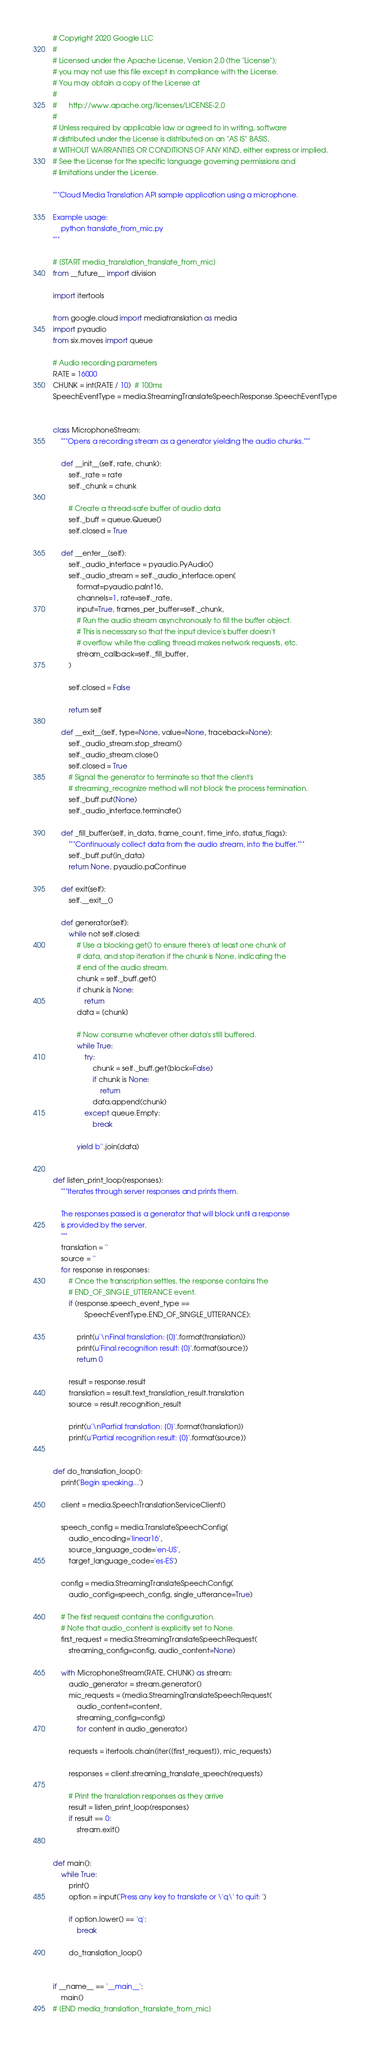<code> <loc_0><loc_0><loc_500><loc_500><_Python_># Copyright 2020 Google LLC
#
# Licensed under the Apache License, Version 2.0 (the "License");
# you may not use this file except in compliance with the License.
# You may obtain a copy of the License at
#
#      http://www.apache.org/licenses/LICENSE-2.0
#
# Unless required by applicable law or agreed to in writing, software
# distributed under the License is distributed on an "AS IS" BASIS,
# WITHOUT WARRANTIES OR CONDITIONS OF ANY KIND, either express or implied.
# See the License for the specific language governing permissions and
# limitations under the License.

"""Cloud Media Translation API sample application using a microphone.

Example usage:
    python translate_from_mic.py
"""

# [START media_translation_translate_from_mic]
from __future__ import division

import itertools

from google.cloud import mediatranslation as media
import pyaudio
from six.moves import queue

# Audio recording parameters
RATE = 16000
CHUNK = int(RATE / 10)  # 100ms
SpeechEventType = media.StreamingTranslateSpeechResponse.SpeechEventType


class MicrophoneStream:
    """Opens a recording stream as a generator yielding the audio chunks."""

    def __init__(self, rate, chunk):
        self._rate = rate
        self._chunk = chunk

        # Create a thread-safe buffer of audio data
        self._buff = queue.Queue()
        self.closed = True

    def __enter__(self):
        self._audio_interface = pyaudio.PyAudio()
        self._audio_stream = self._audio_interface.open(
            format=pyaudio.paInt16,
            channels=1, rate=self._rate,
            input=True, frames_per_buffer=self._chunk,
            # Run the audio stream asynchronously to fill the buffer object.
            # This is necessary so that the input device's buffer doesn't
            # overflow while the calling thread makes network requests, etc.
            stream_callback=self._fill_buffer,
        )

        self.closed = False

        return self

    def __exit__(self, type=None, value=None, traceback=None):
        self._audio_stream.stop_stream()
        self._audio_stream.close()
        self.closed = True
        # Signal the generator to terminate so that the client's
        # streaming_recognize method will not block the process termination.
        self._buff.put(None)
        self._audio_interface.terminate()

    def _fill_buffer(self, in_data, frame_count, time_info, status_flags):
        """Continuously collect data from the audio stream, into the buffer."""
        self._buff.put(in_data)
        return None, pyaudio.paContinue

    def exit(self):
        self.__exit__()

    def generator(self):
        while not self.closed:
            # Use a blocking get() to ensure there's at least one chunk of
            # data, and stop iteration if the chunk is None, indicating the
            # end of the audio stream.
            chunk = self._buff.get()
            if chunk is None:
                return
            data = [chunk]

            # Now consume whatever other data's still buffered.
            while True:
                try:
                    chunk = self._buff.get(block=False)
                    if chunk is None:
                        return
                    data.append(chunk)
                except queue.Empty:
                    break

            yield b''.join(data)


def listen_print_loop(responses):
    """Iterates through server responses and prints them.

    The responses passed is a generator that will block until a response
    is provided by the server.
    """
    translation = ''
    source = ''
    for response in responses:
        # Once the transcription settles, the response contains the
        # END_OF_SINGLE_UTTERANCE event.
        if (response.speech_event_type ==
                SpeechEventType.END_OF_SINGLE_UTTERANCE):

            print(u'\nFinal translation: {0}'.format(translation))
            print(u'Final recognition result: {0}'.format(source))
            return 0

        result = response.result
        translation = result.text_translation_result.translation
        source = result.recognition_result

        print(u'\nPartial translation: {0}'.format(translation))
        print(u'Partial recognition result: {0}'.format(source))


def do_translation_loop():
    print('Begin speaking...')

    client = media.SpeechTranslationServiceClient()

    speech_config = media.TranslateSpeechConfig(
        audio_encoding='linear16',
        source_language_code='en-US',
        target_language_code='es-ES')

    config = media.StreamingTranslateSpeechConfig(
        audio_config=speech_config, single_utterance=True)

    # The first request contains the configuration.
    # Note that audio_content is explicitly set to None.
    first_request = media.StreamingTranslateSpeechRequest(
        streaming_config=config, audio_content=None)

    with MicrophoneStream(RATE, CHUNK) as stream:
        audio_generator = stream.generator()
        mic_requests = (media.StreamingTranslateSpeechRequest(
            audio_content=content,
            streaming_config=config)
            for content in audio_generator)

        requests = itertools.chain(iter([first_request]), mic_requests)

        responses = client.streaming_translate_speech(requests)

        # Print the translation responses as they arrive
        result = listen_print_loop(responses)
        if result == 0:
            stream.exit()


def main():
    while True:
        print()
        option = input('Press any key to translate or \'q\' to quit: ')

        if option.lower() == 'q':
            break

        do_translation_loop()


if __name__ == '__main__':
    main()
# [END media_translation_translate_from_mic]
</code> 